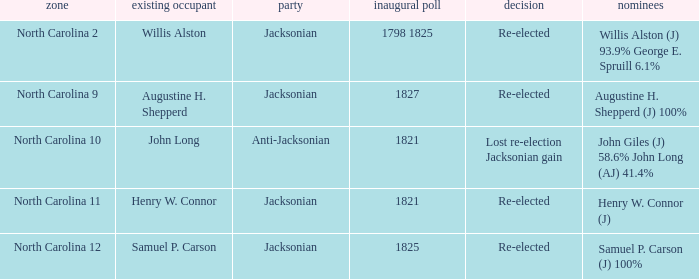Can you parse all the data within this table? {'header': ['zone', 'existing occupant', 'party', 'inaugural poll', 'decision', 'nominees'], 'rows': [['North Carolina 2', 'Willis Alston', 'Jacksonian', '1798 1825', 'Re-elected', 'Willis Alston (J) 93.9% George E. Spruill 6.1%'], ['North Carolina 9', 'Augustine H. Shepperd', 'Jacksonian', '1827', 'Re-elected', 'Augustine H. Shepperd (J) 100%'], ['North Carolina 10', 'John Long', 'Anti-Jacksonian', '1821', 'Lost re-election Jacksonian gain', 'John Giles (J) 58.6% John Long (AJ) 41.4%'], ['North Carolina 11', 'Henry W. Connor', 'Jacksonian', '1821', 'Re-elected', 'Henry W. Connor (J)'], ['North Carolina 12', 'Samuel P. Carson', 'Jacksonian', '1825', 'Re-elected', 'Samuel P. Carson (J) 100%']]} Name the district for anti-jacksonian North Carolina 10. 